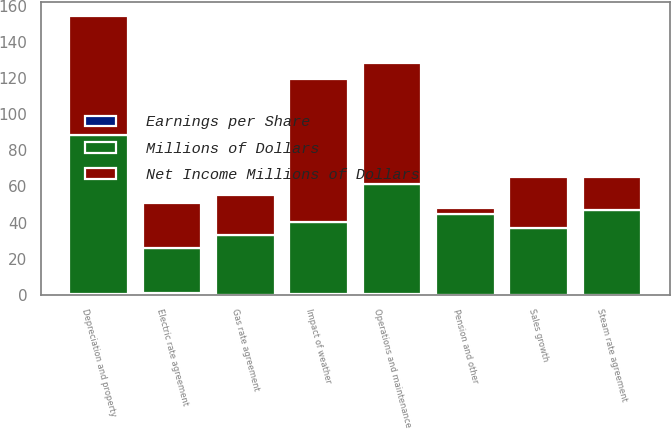<chart> <loc_0><loc_0><loc_500><loc_500><stacked_bar_chart><ecel><fcel>Sales growth<fcel>Impact of weather<fcel>Electric rate agreement<fcel>Gas rate agreement<fcel>Steam rate agreement<fcel>Operations and maintenance<fcel>Depreciation and property<fcel>Pension and other<nl><fcel>Earnings per Share<fcel>0.12<fcel>0.32<fcel>0.74<fcel>0.09<fcel>0.07<fcel>0.28<fcel>0.27<fcel>0.01<nl><fcel>Net Income Millions of Dollars<fcel>28<fcel>79<fcel>25<fcel>22<fcel>18<fcel>67<fcel>66<fcel>3<nl><fcel>Millions of Dollars<fcel>37<fcel>40<fcel>25<fcel>33<fcel>47<fcel>61<fcel>88<fcel>45<nl></chart> 